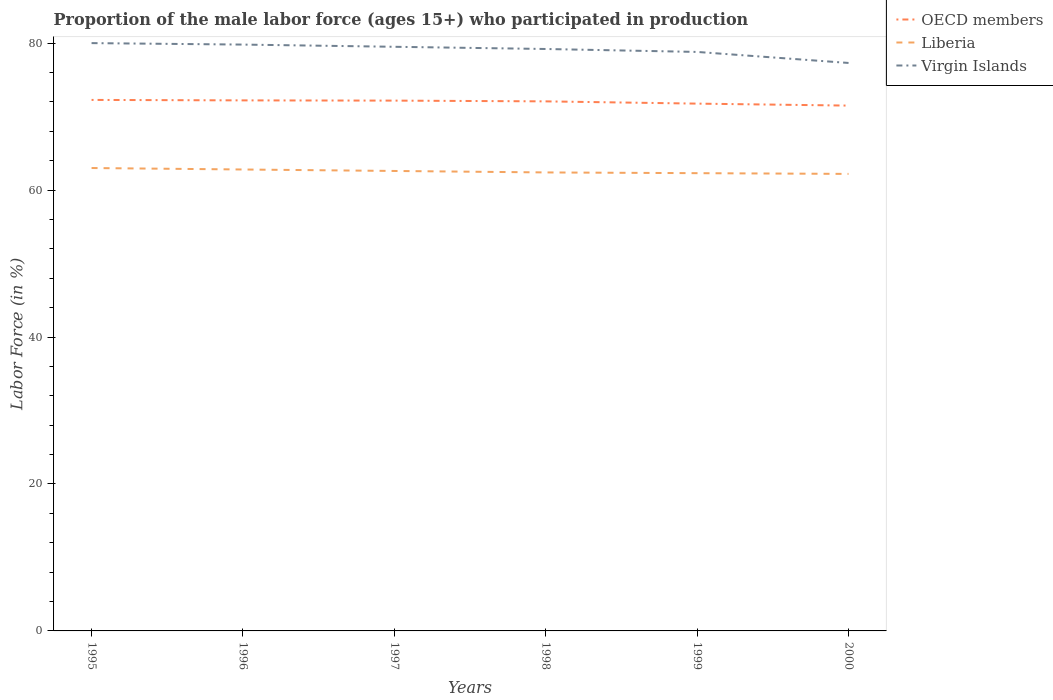Does the line corresponding to Virgin Islands intersect with the line corresponding to Liberia?
Your answer should be very brief. No. Is the number of lines equal to the number of legend labels?
Give a very brief answer. Yes. Across all years, what is the maximum proportion of the male labor force who participated in production in Virgin Islands?
Provide a short and direct response. 77.3. What is the total proportion of the male labor force who participated in production in Liberia in the graph?
Provide a short and direct response. 0.4. What is the difference between the highest and the second highest proportion of the male labor force who participated in production in Liberia?
Provide a short and direct response. 0.8. What is the difference between the highest and the lowest proportion of the male labor force who participated in production in OECD members?
Your answer should be very brief. 4. How many lines are there?
Offer a very short reply. 3. What is the difference between two consecutive major ticks on the Y-axis?
Offer a terse response. 20. Are the values on the major ticks of Y-axis written in scientific E-notation?
Your answer should be very brief. No. Does the graph contain grids?
Provide a succinct answer. No. Where does the legend appear in the graph?
Offer a terse response. Top right. How are the legend labels stacked?
Provide a short and direct response. Vertical. What is the title of the graph?
Provide a succinct answer. Proportion of the male labor force (ages 15+) who participated in production. What is the label or title of the X-axis?
Offer a very short reply. Years. What is the Labor Force (in %) in OECD members in 1995?
Offer a very short reply. 72.27. What is the Labor Force (in %) in Liberia in 1995?
Your answer should be compact. 63. What is the Labor Force (in %) of OECD members in 1996?
Provide a short and direct response. 72.21. What is the Labor Force (in %) of Liberia in 1996?
Offer a very short reply. 62.8. What is the Labor Force (in %) of Virgin Islands in 1996?
Ensure brevity in your answer.  79.8. What is the Labor Force (in %) of OECD members in 1997?
Ensure brevity in your answer.  72.17. What is the Labor Force (in %) in Liberia in 1997?
Make the answer very short. 62.6. What is the Labor Force (in %) in Virgin Islands in 1997?
Keep it short and to the point. 79.5. What is the Labor Force (in %) in OECD members in 1998?
Provide a succinct answer. 72.07. What is the Labor Force (in %) of Liberia in 1998?
Keep it short and to the point. 62.4. What is the Labor Force (in %) in Virgin Islands in 1998?
Provide a succinct answer. 79.2. What is the Labor Force (in %) of OECD members in 1999?
Offer a very short reply. 71.76. What is the Labor Force (in %) in Liberia in 1999?
Offer a very short reply. 62.3. What is the Labor Force (in %) in Virgin Islands in 1999?
Make the answer very short. 78.8. What is the Labor Force (in %) of OECD members in 2000?
Your answer should be compact. 71.5. What is the Labor Force (in %) in Liberia in 2000?
Offer a terse response. 62.2. What is the Labor Force (in %) in Virgin Islands in 2000?
Offer a very short reply. 77.3. Across all years, what is the maximum Labor Force (in %) in OECD members?
Ensure brevity in your answer.  72.27. Across all years, what is the maximum Labor Force (in %) in Virgin Islands?
Give a very brief answer. 80. Across all years, what is the minimum Labor Force (in %) of OECD members?
Your response must be concise. 71.5. Across all years, what is the minimum Labor Force (in %) of Liberia?
Offer a terse response. 62.2. Across all years, what is the minimum Labor Force (in %) of Virgin Islands?
Ensure brevity in your answer.  77.3. What is the total Labor Force (in %) in OECD members in the graph?
Your answer should be compact. 431.98. What is the total Labor Force (in %) of Liberia in the graph?
Give a very brief answer. 375.3. What is the total Labor Force (in %) of Virgin Islands in the graph?
Make the answer very short. 474.6. What is the difference between the Labor Force (in %) of OECD members in 1995 and that in 1996?
Your answer should be compact. 0.06. What is the difference between the Labor Force (in %) of Liberia in 1995 and that in 1996?
Provide a succinct answer. 0.2. What is the difference between the Labor Force (in %) in Virgin Islands in 1995 and that in 1996?
Your answer should be very brief. 0.2. What is the difference between the Labor Force (in %) of OECD members in 1995 and that in 1997?
Your answer should be very brief. 0.09. What is the difference between the Labor Force (in %) in Liberia in 1995 and that in 1997?
Make the answer very short. 0.4. What is the difference between the Labor Force (in %) in Virgin Islands in 1995 and that in 1997?
Give a very brief answer. 0.5. What is the difference between the Labor Force (in %) of OECD members in 1995 and that in 1998?
Make the answer very short. 0.2. What is the difference between the Labor Force (in %) of Liberia in 1995 and that in 1998?
Offer a terse response. 0.6. What is the difference between the Labor Force (in %) in OECD members in 1995 and that in 1999?
Give a very brief answer. 0.5. What is the difference between the Labor Force (in %) of Liberia in 1995 and that in 1999?
Provide a short and direct response. 0.7. What is the difference between the Labor Force (in %) in OECD members in 1995 and that in 2000?
Give a very brief answer. 0.77. What is the difference between the Labor Force (in %) of OECD members in 1996 and that in 1997?
Give a very brief answer. 0.03. What is the difference between the Labor Force (in %) in Liberia in 1996 and that in 1997?
Provide a succinct answer. 0.2. What is the difference between the Labor Force (in %) of OECD members in 1996 and that in 1998?
Keep it short and to the point. 0.13. What is the difference between the Labor Force (in %) in OECD members in 1996 and that in 1999?
Provide a succinct answer. 0.44. What is the difference between the Labor Force (in %) in OECD members in 1996 and that in 2000?
Give a very brief answer. 0.71. What is the difference between the Labor Force (in %) in Virgin Islands in 1996 and that in 2000?
Your answer should be compact. 2.5. What is the difference between the Labor Force (in %) of OECD members in 1997 and that in 1998?
Ensure brevity in your answer.  0.1. What is the difference between the Labor Force (in %) in OECD members in 1997 and that in 1999?
Your answer should be very brief. 0.41. What is the difference between the Labor Force (in %) in Virgin Islands in 1997 and that in 1999?
Keep it short and to the point. 0.7. What is the difference between the Labor Force (in %) of OECD members in 1997 and that in 2000?
Give a very brief answer. 0.68. What is the difference between the Labor Force (in %) in OECD members in 1998 and that in 1999?
Your response must be concise. 0.31. What is the difference between the Labor Force (in %) in Virgin Islands in 1998 and that in 1999?
Give a very brief answer. 0.4. What is the difference between the Labor Force (in %) in OECD members in 1998 and that in 2000?
Provide a short and direct response. 0.58. What is the difference between the Labor Force (in %) of OECD members in 1999 and that in 2000?
Make the answer very short. 0.27. What is the difference between the Labor Force (in %) of Liberia in 1999 and that in 2000?
Your answer should be very brief. 0.1. What is the difference between the Labor Force (in %) in Virgin Islands in 1999 and that in 2000?
Your response must be concise. 1.5. What is the difference between the Labor Force (in %) in OECD members in 1995 and the Labor Force (in %) in Liberia in 1996?
Your answer should be very brief. 9.47. What is the difference between the Labor Force (in %) of OECD members in 1995 and the Labor Force (in %) of Virgin Islands in 1996?
Your response must be concise. -7.53. What is the difference between the Labor Force (in %) of Liberia in 1995 and the Labor Force (in %) of Virgin Islands in 1996?
Offer a terse response. -16.8. What is the difference between the Labor Force (in %) of OECD members in 1995 and the Labor Force (in %) of Liberia in 1997?
Provide a succinct answer. 9.67. What is the difference between the Labor Force (in %) of OECD members in 1995 and the Labor Force (in %) of Virgin Islands in 1997?
Ensure brevity in your answer.  -7.23. What is the difference between the Labor Force (in %) of Liberia in 1995 and the Labor Force (in %) of Virgin Islands in 1997?
Your response must be concise. -16.5. What is the difference between the Labor Force (in %) in OECD members in 1995 and the Labor Force (in %) in Liberia in 1998?
Your answer should be very brief. 9.87. What is the difference between the Labor Force (in %) of OECD members in 1995 and the Labor Force (in %) of Virgin Islands in 1998?
Offer a very short reply. -6.93. What is the difference between the Labor Force (in %) in Liberia in 1995 and the Labor Force (in %) in Virgin Islands in 1998?
Keep it short and to the point. -16.2. What is the difference between the Labor Force (in %) in OECD members in 1995 and the Labor Force (in %) in Liberia in 1999?
Make the answer very short. 9.97. What is the difference between the Labor Force (in %) in OECD members in 1995 and the Labor Force (in %) in Virgin Islands in 1999?
Ensure brevity in your answer.  -6.53. What is the difference between the Labor Force (in %) in Liberia in 1995 and the Labor Force (in %) in Virgin Islands in 1999?
Ensure brevity in your answer.  -15.8. What is the difference between the Labor Force (in %) of OECD members in 1995 and the Labor Force (in %) of Liberia in 2000?
Provide a succinct answer. 10.07. What is the difference between the Labor Force (in %) of OECD members in 1995 and the Labor Force (in %) of Virgin Islands in 2000?
Make the answer very short. -5.03. What is the difference between the Labor Force (in %) of Liberia in 1995 and the Labor Force (in %) of Virgin Islands in 2000?
Offer a terse response. -14.3. What is the difference between the Labor Force (in %) of OECD members in 1996 and the Labor Force (in %) of Liberia in 1997?
Offer a terse response. 9.61. What is the difference between the Labor Force (in %) in OECD members in 1996 and the Labor Force (in %) in Virgin Islands in 1997?
Offer a terse response. -7.29. What is the difference between the Labor Force (in %) in Liberia in 1996 and the Labor Force (in %) in Virgin Islands in 1997?
Provide a short and direct response. -16.7. What is the difference between the Labor Force (in %) in OECD members in 1996 and the Labor Force (in %) in Liberia in 1998?
Provide a short and direct response. 9.81. What is the difference between the Labor Force (in %) of OECD members in 1996 and the Labor Force (in %) of Virgin Islands in 1998?
Your answer should be very brief. -6.99. What is the difference between the Labor Force (in %) of Liberia in 1996 and the Labor Force (in %) of Virgin Islands in 1998?
Your answer should be very brief. -16.4. What is the difference between the Labor Force (in %) of OECD members in 1996 and the Labor Force (in %) of Liberia in 1999?
Your answer should be very brief. 9.91. What is the difference between the Labor Force (in %) of OECD members in 1996 and the Labor Force (in %) of Virgin Islands in 1999?
Your response must be concise. -6.59. What is the difference between the Labor Force (in %) of Liberia in 1996 and the Labor Force (in %) of Virgin Islands in 1999?
Your answer should be compact. -16. What is the difference between the Labor Force (in %) in OECD members in 1996 and the Labor Force (in %) in Liberia in 2000?
Your answer should be very brief. 10.01. What is the difference between the Labor Force (in %) in OECD members in 1996 and the Labor Force (in %) in Virgin Islands in 2000?
Offer a terse response. -5.09. What is the difference between the Labor Force (in %) of OECD members in 1997 and the Labor Force (in %) of Liberia in 1998?
Offer a terse response. 9.77. What is the difference between the Labor Force (in %) in OECD members in 1997 and the Labor Force (in %) in Virgin Islands in 1998?
Make the answer very short. -7.03. What is the difference between the Labor Force (in %) of Liberia in 1997 and the Labor Force (in %) of Virgin Islands in 1998?
Provide a short and direct response. -16.6. What is the difference between the Labor Force (in %) of OECD members in 1997 and the Labor Force (in %) of Liberia in 1999?
Your response must be concise. 9.87. What is the difference between the Labor Force (in %) of OECD members in 1997 and the Labor Force (in %) of Virgin Islands in 1999?
Make the answer very short. -6.63. What is the difference between the Labor Force (in %) of Liberia in 1997 and the Labor Force (in %) of Virgin Islands in 1999?
Keep it short and to the point. -16.2. What is the difference between the Labor Force (in %) in OECD members in 1997 and the Labor Force (in %) in Liberia in 2000?
Give a very brief answer. 9.97. What is the difference between the Labor Force (in %) of OECD members in 1997 and the Labor Force (in %) of Virgin Islands in 2000?
Ensure brevity in your answer.  -5.13. What is the difference between the Labor Force (in %) of Liberia in 1997 and the Labor Force (in %) of Virgin Islands in 2000?
Keep it short and to the point. -14.7. What is the difference between the Labor Force (in %) of OECD members in 1998 and the Labor Force (in %) of Liberia in 1999?
Ensure brevity in your answer.  9.77. What is the difference between the Labor Force (in %) of OECD members in 1998 and the Labor Force (in %) of Virgin Islands in 1999?
Give a very brief answer. -6.73. What is the difference between the Labor Force (in %) in Liberia in 1998 and the Labor Force (in %) in Virgin Islands in 1999?
Offer a terse response. -16.4. What is the difference between the Labor Force (in %) in OECD members in 1998 and the Labor Force (in %) in Liberia in 2000?
Give a very brief answer. 9.87. What is the difference between the Labor Force (in %) in OECD members in 1998 and the Labor Force (in %) in Virgin Islands in 2000?
Your answer should be very brief. -5.23. What is the difference between the Labor Force (in %) of Liberia in 1998 and the Labor Force (in %) of Virgin Islands in 2000?
Offer a very short reply. -14.9. What is the difference between the Labor Force (in %) in OECD members in 1999 and the Labor Force (in %) in Liberia in 2000?
Provide a succinct answer. 9.56. What is the difference between the Labor Force (in %) of OECD members in 1999 and the Labor Force (in %) of Virgin Islands in 2000?
Offer a very short reply. -5.54. What is the average Labor Force (in %) in OECD members per year?
Offer a very short reply. 72. What is the average Labor Force (in %) in Liberia per year?
Offer a very short reply. 62.55. What is the average Labor Force (in %) in Virgin Islands per year?
Offer a terse response. 79.1. In the year 1995, what is the difference between the Labor Force (in %) of OECD members and Labor Force (in %) of Liberia?
Ensure brevity in your answer.  9.27. In the year 1995, what is the difference between the Labor Force (in %) of OECD members and Labor Force (in %) of Virgin Islands?
Your response must be concise. -7.73. In the year 1996, what is the difference between the Labor Force (in %) of OECD members and Labor Force (in %) of Liberia?
Your response must be concise. 9.41. In the year 1996, what is the difference between the Labor Force (in %) in OECD members and Labor Force (in %) in Virgin Islands?
Your answer should be very brief. -7.59. In the year 1997, what is the difference between the Labor Force (in %) in OECD members and Labor Force (in %) in Liberia?
Your answer should be compact. 9.57. In the year 1997, what is the difference between the Labor Force (in %) in OECD members and Labor Force (in %) in Virgin Islands?
Keep it short and to the point. -7.33. In the year 1997, what is the difference between the Labor Force (in %) in Liberia and Labor Force (in %) in Virgin Islands?
Give a very brief answer. -16.9. In the year 1998, what is the difference between the Labor Force (in %) in OECD members and Labor Force (in %) in Liberia?
Keep it short and to the point. 9.67. In the year 1998, what is the difference between the Labor Force (in %) of OECD members and Labor Force (in %) of Virgin Islands?
Make the answer very short. -7.13. In the year 1998, what is the difference between the Labor Force (in %) of Liberia and Labor Force (in %) of Virgin Islands?
Give a very brief answer. -16.8. In the year 1999, what is the difference between the Labor Force (in %) in OECD members and Labor Force (in %) in Liberia?
Ensure brevity in your answer.  9.46. In the year 1999, what is the difference between the Labor Force (in %) of OECD members and Labor Force (in %) of Virgin Islands?
Make the answer very short. -7.04. In the year 1999, what is the difference between the Labor Force (in %) in Liberia and Labor Force (in %) in Virgin Islands?
Give a very brief answer. -16.5. In the year 2000, what is the difference between the Labor Force (in %) in OECD members and Labor Force (in %) in Liberia?
Give a very brief answer. 9.3. In the year 2000, what is the difference between the Labor Force (in %) of OECD members and Labor Force (in %) of Virgin Islands?
Your answer should be very brief. -5.8. In the year 2000, what is the difference between the Labor Force (in %) in Liberia and Labor Force (in %) in Virgin Islands?
Offer a terse response. -15.1. What is the ratio of the Labor Force (in %) in OECD members in 1995 to that in 1996?
Offer a very short reply. 1. What is the ratio of the Labor Force (in %) of Liberia in 1995 to that in 1996?
Provide a succinct answer. 1. What is the ratio of the Labor Force (in %) of Liberia in 1995 to that in 1997?
Your answer should be very brief. 1.01. What is the ratio of the Labor Force (in %) in Virgin Islands in 1995 to that in 1997?
Your answer should be compact. 1.01. What is the ratio of the Labor Force (in %) in OECD members in 1995 to that in 1998?
Make the answer very short. 1. What is the ratio of the Labor Force (in %) in Liberia in 1995 to that in 1998?
Offer a terse response. 1.01. What is the ratio of the Labor Force (in %) of Liberia in 1995 to that in 1999?
Offer a terse response. 1.01. What is the ratio of the Labor Force (in %) in Virgin Islands in 1995 to that in 1999?
Offer a terse response. 1.02. What is the ratio of the Labor Force (in %) of OECD members in 1995 to that in 2000?
Your answer should be very brief. 1.01. What is the ratio of the Labor Force (in %) in Liberia in 1995 to that in 2000?
Provide a succinct answer. 1.01. What is the ratio of the Labor Force (in %) in Virgin Islands in 1995 to that in 2000?
Give a very brief answer. 1.03. What is the ratio of the Labor Force (in %) of OECD members in 1996 to that in 1997?
Give a very brief answer. 1. What is the ratio of the Labor Force (in %) in Liberia in 1996 to that in 1997?
Your response must be concise. 1. What is the ratio of the Labor Force (in %) of Liberia in 1996 to that in 1998?
Offer a very short reply. 1.01. What is the ratio of the Labor Force (in %) of Virgin Islands in 1996 to that in 1998?
Ensure brevity in your answer.  1.01. What is the ratio of the Labor Force (in %) of OECD members in 1996 to that in 1999?
Ensure brevity in your answer.  1.01. What is the ratio of the Labor Force (in %) of Liberia in 1996 to that in 1999?
Your answer should be compact. 1.01. What is the ratio of the Labor Force (in %) in Virgin Islands in 1996 to that in 1999?
Your answer should be very brief. 1.01. What is the ratio of the Labor Force (in %) in OECD members in 1996 to that in 2000?
Ensure brevity in your answer.  1.01. What is the ratio of the Labor Force (in %) in Liberia in 1996 to that in 2000?
Your answer should be very brief. 1.01. What is the ratio of the Labor Force (in %) of Virgin Islands in 1996 to that in 2000?
Give a very brief answer. 1.03. What is the ratio of the Labor Force (in %) in OECD members in 1997 to that in 1998?
Your response must be concise. 1. What is the ratio of the Labor Force (in %) of Virgin Islands in 1997 to that in 1998?
Your response must be concise. 1. What is the ratio of the Labor Force (in %) of Liberia in 1997 to that in 1999?
Ensure brevity in your answer.  1. What is the ratio of the Labor Force (in %) in Virgin Islands in 1997 to that in 1999?
Provide a short and direct response. 1.01. What is the ratio of the Labor Force (in %) in OECD members in 1997 to that in 2000?
Offer a terse response. 1.01. What is the ratio of the Labor Force (in %) in Liberia in 1997 to that in 2000?
Provide a short and direct response. 1.01. What is the ratio of the Labor Force (in %) of Virgin Islands in 1997 to that in 2000?
Your answer should be very brief. 1.03. What is the ratio of the Labor Force (in %) in OECD members in 1998 to that in 1999?
Keep it short and to the point. 1. What is the ratio of the Labor Force (in %) in Liberia in 1998 to that in 1999?
Offer a very short reply. 1. What is the ratio of the Labor Force (in %) of Virgin Islands in 1998 to that in 1999?
Ensure brevity in your answer.  1.01. What is the ratio of the Labor Force (in %) in OECD members in 1998 to that in 2000?
Provide a short and direct response. 1.01. What is the ratio of the Labor Force (in %) in Virgin Islands in 1998 to that in 2000?
Provide a succinct answer. 1.02. What is the ratio of the Labor Force (in %) of Liberia in 1999 to that in 2000?
Provide a short and direct response. 1. What is the ratio of the Labor Force (in %) in Virgin Islands in 1999 to that in 2000?
Give a very brief answer. 1.02. What is the difference between the highest and the second highest Labor Force (in %) of OECD members?
Your response must be concise. 0.06. What is the difference between the highest and the second highest Labor Force (in %) of Virgin Islands?
Your answer should be compact. 0.2. What is the difference between the highest and the lowest Labor Force (in %) in OECD members?
Your response must be concise. 0.77. What is the difference between the highest and the lowest Labor Force (in %) of Liberia?
Offer a terse response. 0.8. What is the difference between the highest and the lowest Labor Force (in %) of Virgin Islands?
Your answer should be very brief. 2.7. 